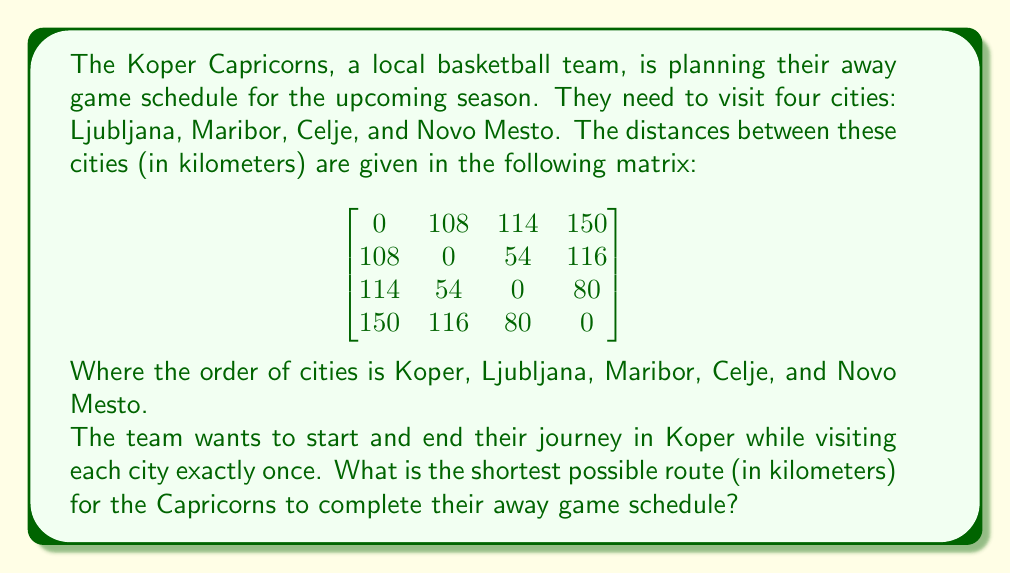Give your solution to this math problem. To solve this problem, we need to find the shortest Hamiltonian cycle in the given graph, which is known as the Traveling Salesman Problem (TSP). For a small number of cities like in this case, we can use the brute-force method to find the optimal solution.

Let's list all possible routes starting and ending in Koper:

1. Koper - Ljubljana - Maribor - Celje - Novo Mesto - Koper
2. Koper - Ljubljana - Maribor - Novo Mesto - Celje - Koper
3. Koper - Ljubljana - Celje - Maribor - Novo Mesto - Koper
4. Koper - Ljubljana - Celje - Novo Mesto - Maribor - Koper
5. Koper - Ljubljana - Novo Mesto - Maribor - Celje - Koper
6. Koper - Ljubljana - Novo Mesto - Celje - Maribor - Koper

Now, let's calculate the total distance for each route:

1. $108 + 54 + 80 + 150 = 392$ km
2. $108 + 54 + 116 + 114 = 392$ km
3. $108 + 54 + 54 + 150 = 366$ km
4. $108 + 54 + 80 + 108 = 350$ km
5. $108 + 116 + 54 + 114 = 392$ km
6. $108 + 116 + 54 + 108 = 386$ km

The shortest route is option 4: Koper - Ljubljana - Celje - Novo Mesto - Maribor - Koper, with a total distance of 350 km.
Answer: The shortest possible route for the Koper Capricorns to complete their away game schedule is 350 km. 